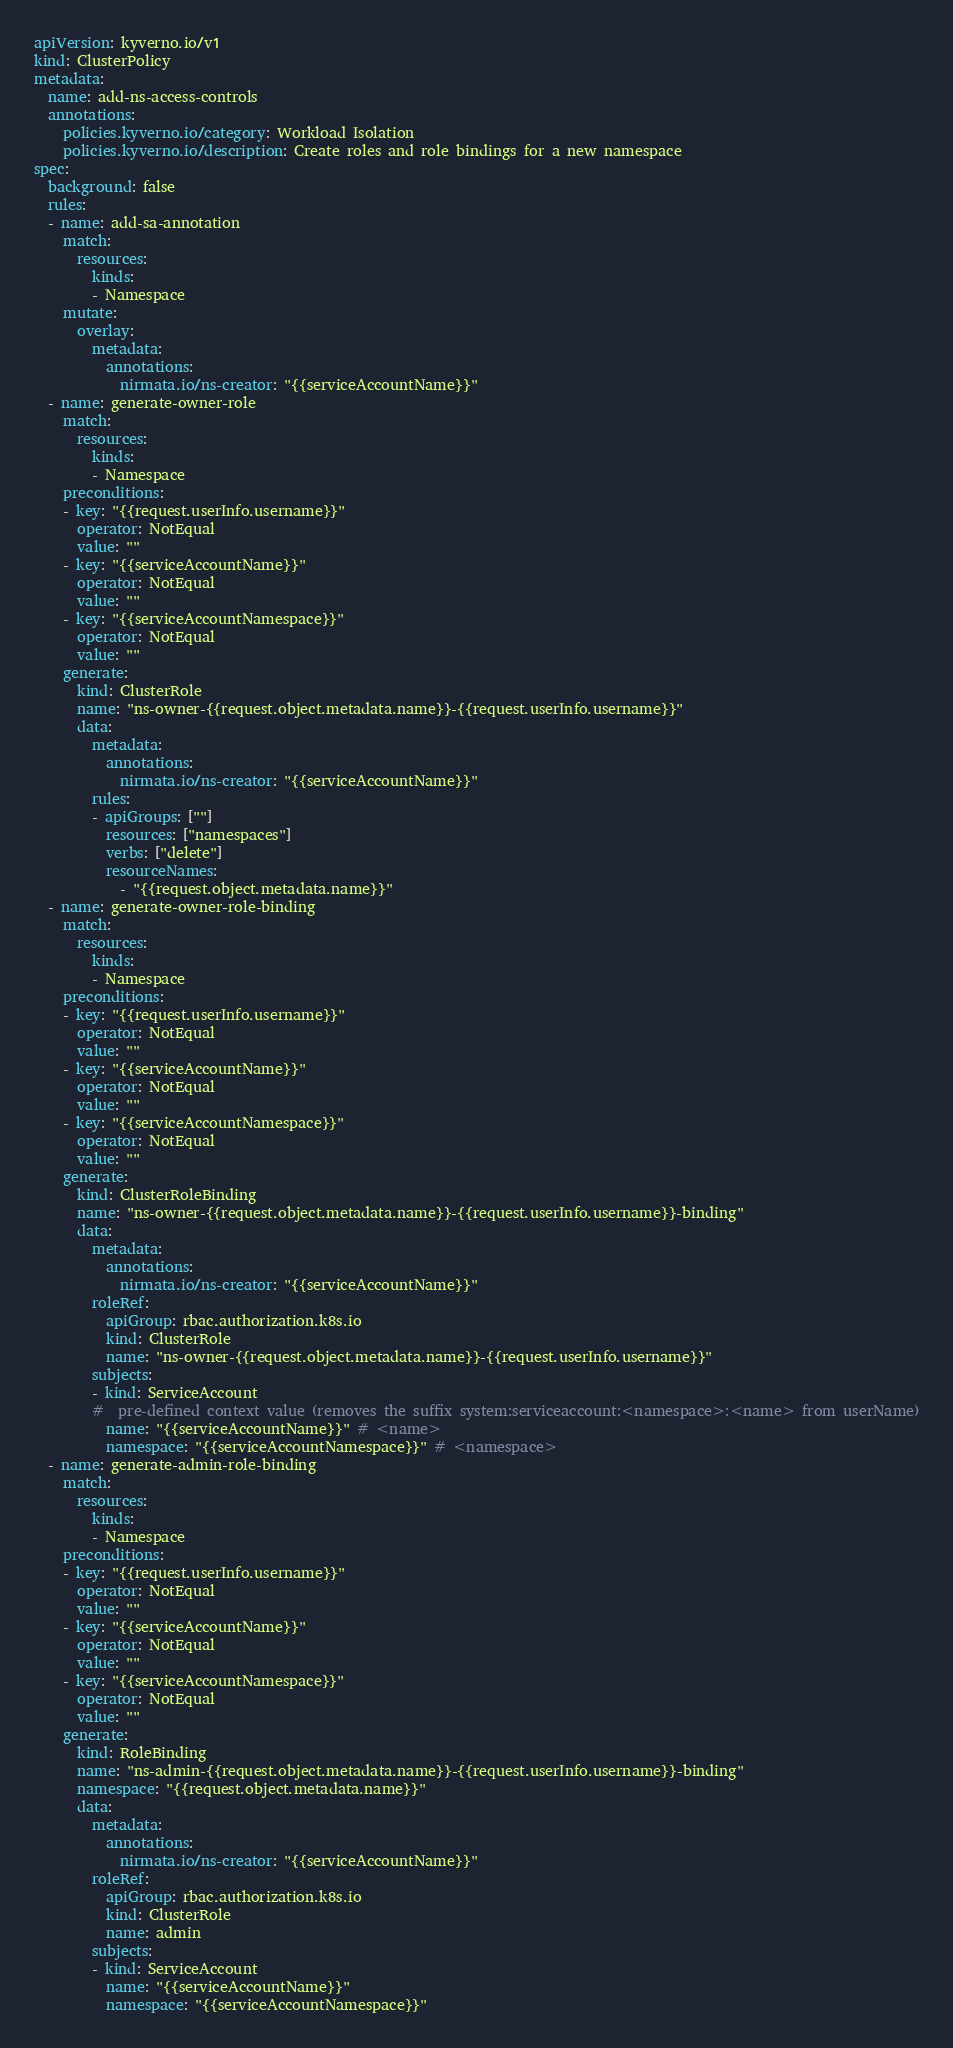<code> <loc_0><loc_0><loc_500><loc_500><_YAML_>apiVersion: kyverno.io/v1
kind: ClusterPolicy
metadata:
  name: add-ns-access-controls
  annotations:
    policies.kyverno.io/category: Workload Isolation
    policies.kyverno.io/description: Create roles and role bindings for a new namespace
spec:
  background: false
  rules:
  - name: add-sa-annotation
    match:
      resources:
        kinds:
        - Namespace
    mutate:
      overlay:
        metadata:
          annotations:
            nirmata.io/ns-creator: "{{serviceAccountName}}"
  - name: generate-owner-role
    match:
      resources:
        kinds:
        - Namespace
    preconditions:
    - key: "{{request.userInfo.username}}"
      operator: NotEqual
      value: ""
    - key: "{{serviceAccountName}}"
      operator: NotEqual
      value: ""
    - key: "{{serviceAccountNamespace}}"
      operator: NotEqual
      value: ""
    generate:
      kind: ClusterRole
      name: "ns-owner-{{request.object.metadata.name}}-{{request.userInfo.username}}"
      data:
        metadata:
          annotations:
            nirmata.io/ns-creator: "{{serviceAccountName}}"
        rules:
        - apiGroups: [""]
          resources: ["namespaces"]
          verbs: ["delete"]
          resourceNames:
            - "{{request.object.metadata.name}}"
  - name: generate-owner-role-binding
    match:
      resources:
        kinds:
        - Namespace
    preconditions:
    - key: "{{request.userInfo.username}}"
      operator: NotEqual
      value: ""
    - key: "{{serviceAccountName}}"
      operator: NotEqual
      value: ""
    - key: "{{serviceAccountNamespace}}"
      operator: NotEqual
      value: ""
    generate:
      kind: ClusterRoleBinding
      name: "ns-owner-{{request.object.metadata.name}}-{{request.userInfo.username}}-binding"
      data:
        metadata:
          annotations:
            nirmata.io/ns-creator: "{{serviceAccountName}}"
        roleRef:
          apiGroup: rbac.authorization.k8s.io
          kind: ClusterRole
          name: "ns-owner-{{request.object.metadata.name}}-{{request.userInfo.username}}"
        subjects:
        - kind: ServiceAccount
        #  pre-defined context value (removes the suffix system:serviceaccount:<namespace>:<name> from userName)
          name: "{{serviceAccountName}}" # <name>
          namespace: "{{serviceAccountNamespace}}" # <namespace>
  - name: generate-admin-role-binding
    match:
      resources:
        kinds:
        - Namespace
    preconditions:
    - key: "{{request.userInfo.username}}"
      operator: NotEqual
      value: ""
    - key: "{{serviceAccountName}}"
      operator: NotEqual
      value: ""
    - key: "{{serviceAccountNamespace}}"
      operator: NotEqual
      value: ""
    generate:
      kind: RoleBinding
      name: "ns-admin-{{request.object.metadata.name}}-{{request.userInfo.username}}-binding"
      namespace: "{{request.object.metadata.name}}"
      data:
        metadata:
          annotations:
            nirmata.io/ns-creator: "{{serviceAccountName}}"
        roleRef:
          apiGroup: rbac.authorization.k8s.io
          kind: ClusterRole
          name: admin
        subjects:
        - kind: ServiceAccount
          name: "{{serviceAccountName}}"
          namespace: "{{serviceAccountNamespace}}"</code> 